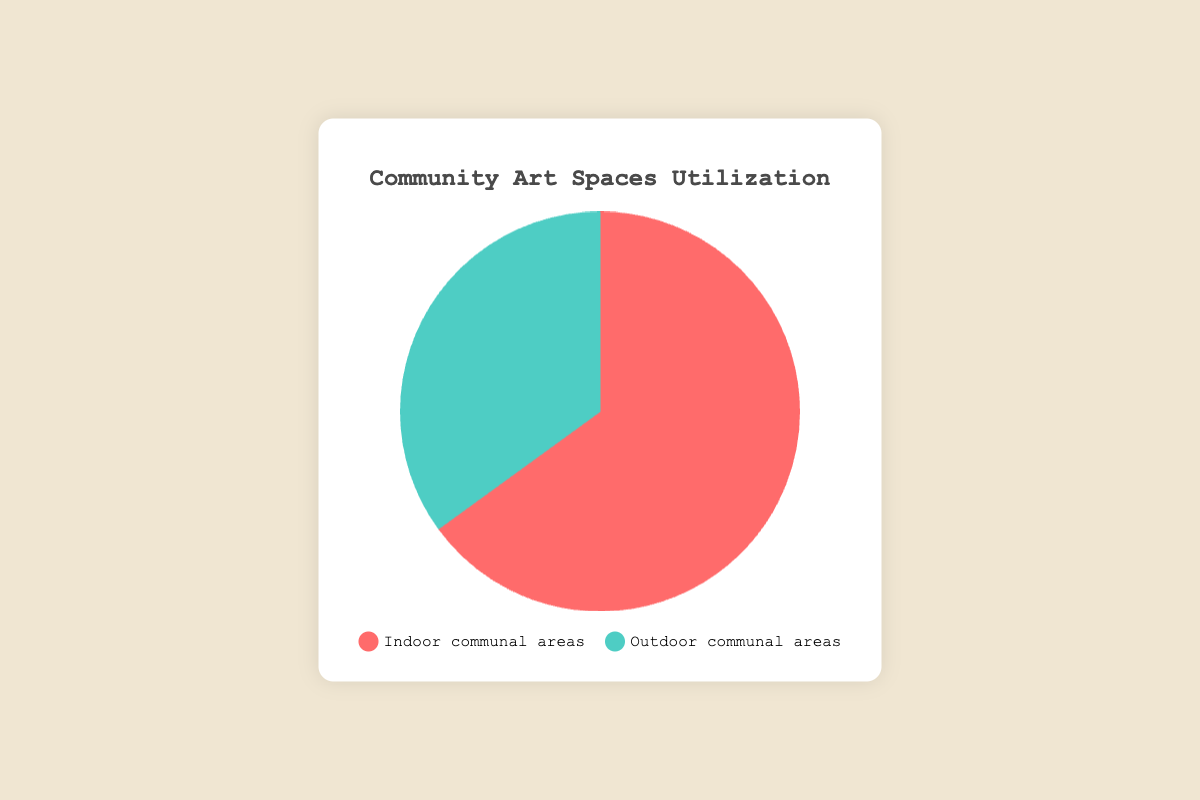What percentage of the communal areas used for galleries are indoor? The pie chart shows two segments with their respective percentages. The red segment for indoor communal areas is labeled 65%.
Answer: 65% What percentage of the communal areas used for galleries are outdoor? The pie chart shows two segments with their respective percentages. The green segment for outdoor communal areas is labeled 35%.
Answer: 35% Are indoor or outdoor communal areas more utilized for galleries? By comparing the segment sizes, the red segment representing indoor communal areas (65%) is larger than the green segment representing outdoor communal areas (35%).
Answer: Indoor communal areas What is the difference in usage percentage between indoor and outdoor communal areas? The indoor usage is 65% and outdoor usage is 35%. Subtract the smaller percentage from the larger one: 65% - 35% = 30%.
Answer: 30% What is the sum of the percentages for both communal areas? The pie chart splits the total usage into two segments: indoor (65%) and outdoor (35%). Summing these values gives 65% + 35% = 100%.
Answer: 100% 